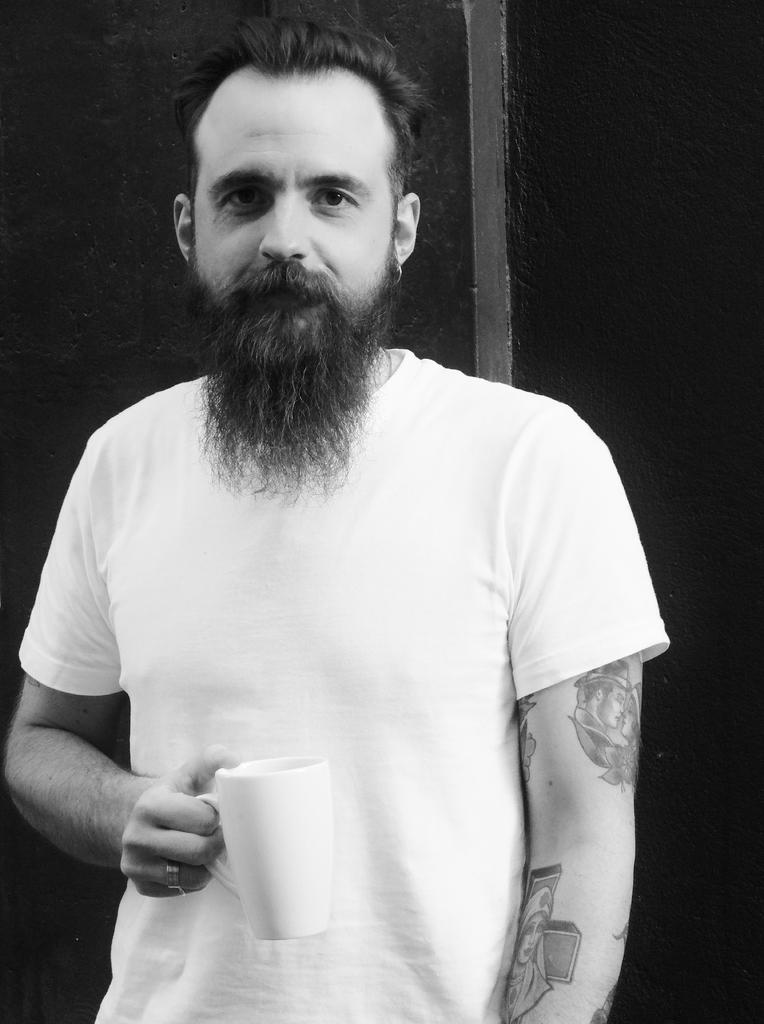Who or what is the main subject of the image? There is a person in the image. What is the person holding in the image? The person is holding a cup. What is the person's facial expression or action in the image? The person is looking at the camera. What type of skin condition does the person have in the image? There is no indication of a skin condition in the image; we can only see the person holding a cup and looking at the camera. 